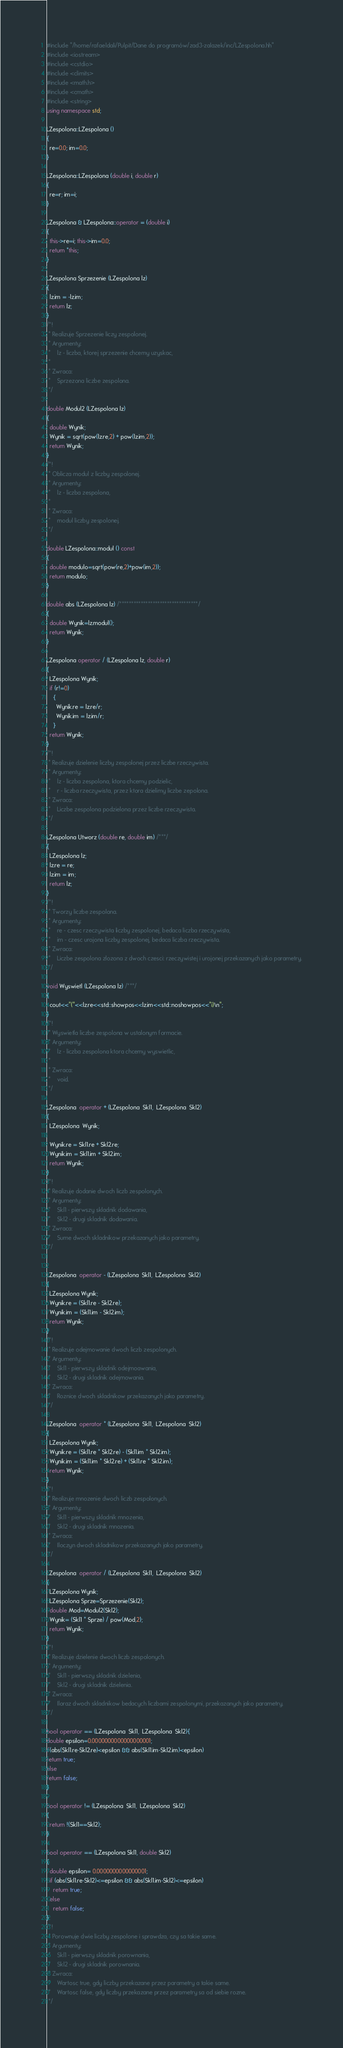Convert code to text. <code><loc_0><loc_0><loc_500><loc_500><_C++_>#include "/home/rafaeldali/Pulpit/Dane do programów/zad3-zalazek/inc/LZespolona.hh"
#include <iostream>
#include <cstdio>
#include <climits>
#include <math.h>
#include <cmath>
#include <string>
using namespace std;

LZespolona::LZespolona ()
{
  re=0.0; im=0.0;
}

LZespolona::LZespolona (double i, double r)
{
  re=r; im=i;
}

LZespolona & LZespolona::operator = (double i)
{
  this->re=i; this->im=0.0;
  return *this;
}

LZespolona Sprzezenie (LZespolona lz)
{
  lz.im = -lz.im;
  return lz;
}
/*!
 * Realizuje Sprzezenie liczy zespolonej.
 * Argumenty:
 *    lz - liczba, ktorej sprzezenie chcemy uzyskac,
 *   
 * Zwraca:
 *    Sprzezona liczbe zespolona.
 */

double Modul2 (LZespolona lz)
{
  double Wynik;
  Wynik = sqrt(pow(lz.re,2) + pow(lz.im,2));
  return Wynik;
}
/*!
 * Oblicza modul z liczby zespolonej.
 * Argumenty:
 *    lz - liczba zespolona,
 *    
 * Zwraca:
 *    modul liczby zespolonej.
 */

double LZespolona::modul () const 
{
  double modulo=sqrt(pow(re,2)+pow(im,2));
  return modulo;
}

double abs (LZespolona lz) /*********************************/
{
  double Wynik=lz.modul();
  return Wynik;
}

LZespolona operator / (LZespolona lz, double r)
{
  LZespolona Wynik;
  if (r!=0)
    {
      Wynik.re = lz.re/r;
      Wynik.im = lz.im/r;
    }
  return Wynik;
}
/*!
 * Realizuje dzielenie liczby zespolonej przez liczbe rzeczywista.
 * Argumenty:
 *    lz - liczba zespolona, ktora chcemy podzielic,
 *    r - liczba rzeczywista, przez ktora dzielimy liczbe zepolona.
 * Zwraca:
 *    Liczbe zespolona podzielona przez liczbe rzeczywista.
 */

LZespolona Utworz (double re, double im) /***/
{
  LZespolona lz;
  lz.re = re;
  lz.im = im;
  return lz;
}
/*!
 * Tworzy liczbe zespolona.
 * Argumenty:
 *    re - czesc rzeczywista liczby zespolonej, bedaca liczba rzeczywista,
 *    im - czesc urojona liczby zespolonej, bedaca liczba rzeczywista.
 * Zwraca:
 *    Liczbe zespolona zlozona z dwoch czesci: rzeczywistej i urojonej przekazanych jako parametry.
 */

void Wyswietl (LZespolona lz) /***/
{
  cout<<"("<<lz.re<<std::showpos<<lz.im<<std::noshowpos<<"i)\n";
}
/*!
 * Wyswietla liczbe zespolona w ustalonym formacie.
 * Argumenty:
 *    lz - liczba zespolona ktora chcemy wyswietlic,
 *    
 * Zwraca:
 *    void.
 */

LZespolona  operator + (LZespolona  Skl1,  LZespolona  Skl2)
{
  LZespolona  Wynik;

  Wynik.re = Skl1.re + Skl2.re;
  Wynik.im = Skl1.im + Skl2.im;
  return Wynik;
}
/*!
 * Realizuje dodanie dwoch liczb zespolonych.
 * Argumenty:
 *    Skl1 - pierwszy skladnik dodawania,
 *    Skl2 - drugi skladnik dodawania.
 * Zwraca:
 *    Sume dwoch skladnikow przekazanych jako parametry.
 */


LZespolona  operator - (LZespolona  Skl1,  LZespolona  Skl2)
{
  LZespolona Wynik;
  Wynik.re = (Skl1.re - Skl2.re);
  Wynik.im = (Skl1.im - Skl2.im);
  return Wynik;
}
/*!
 * Realizuje odejmowanie dwoch liczb zespolonych.
 * Argumenty:
 *    Skl1 - pierwszy skladnik odejmoawania,
 *    Skl2 - drugi skladnik odejmowania.
 * Zwraca:
 *    Roznice dwoch skladnikow przekazanych jako parametry.
 */

LZespolona  operator * (LZespolona  Skl1,  LZespolona  Skl2)
{
  LZespolona Wynik;
  Wynik.re = (Skl1.re * Skl2.re) - (Skl1.im * Skl2.im);
  Wynik.im = (Skl1.im * Skl2.re) + (Skl1.re * Skl2.im);
  return Wynik;
}
/*!
 * Realizuje mnozenie dwoch liczb zespolonych.
 * Argumenty:
 *    Skl1 - pierwszy skladnik mnozenia,
 *    Skl2 - drugi skladnik mnozenia.
 * Zwraca:
 *    Iloczyn dwoch skladnikow przekazanych jako parametry.
 */

LZespolona  operator / (LZespolona  Skl1,  LZespolona  Skl2)
{
  LZespolona Wynik;
  LZespolona Sprze=Sprzezenie(Skl2);
  double Mod=Modul2(Skl2);
  Wynik= (Skl1 * Sprze) / pow(Mod,2);
  return Wynik;  
}
/*!
 * Realizuje dzielenie dwoch liczb zespolonych.
 * Argumenty:
 *    Skl1 - pierwszy skladnik dzielenia,
 *    Skl2 - drugi skladnik dzielenia.
 * Zwraca:
 *    Iloraz dwoch skladnikow bedacych liczbami zespolonymi, przekazanych jako parametry.
 */

bool operator == (LZespolona  Skl1,  LZespolona  Skl2){
double epsilon=0.0000000000000000001;
if(abs(Skl1.re-Skl2.re)<epsilon && abs(Skl1.im-Skl2.im)<epsilon)
return true;
else
return false;
}

bool operator != (LZespolona  Skl1,  LZespolona  Skl2)
{
  return !(Skl1==Skl2);
}

bool operator == (LZespolona Skl1, double Skl2)
{
  double epsilon= 0.0000000000000001;
  if (abs(Skl1.re-Skl2)<=epsilon && abs(Skl1.im-Skl2)<=epsilon)
    return true;
  else
    return false;
}
/*!
 * Porownuje dwie liczby zespolone i sprawdza, czy sa takie same.
 * Argumenty:
 *    Skl1 - pierwszy skladnik porownania,
 *    Skl2 - drugi skladnik porownania.
 * Zwraca:
 *    Wartosc true, gdy liczby przekazane przez parametry a takie same.
 *    Wartosc false, gdy liczby przekazane przez parametry sa od siebie rozne.
 */
</code> 